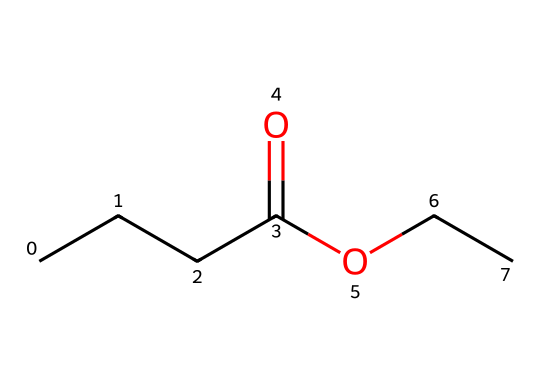What is the molecular formula of ethyl butyrate? To find the molecular formula, we need to count the number of each type of atom in the chemical structure represented by the SMILES. There are 6 carbon (C) atoms, 12 hydrogen (H) atoms, and 2 oxygen (O) atoms, which gives the molecular formula C6H12O2.
Answer: C6H12O2 How many carbon atoms are in ethyl butyrate? By examining the SMILES representation, we can count the carbon atoms. There are a total of 6 carbon atoms in the structure.
Answer: 6 What type of functional group is present in ethyl butyrate? Looking at the SMILES representation, we identify a carbonyl (C=O) and a hydroxy group (O), indicating the presence of an ester functional group.
Answer: ester What part of the structure contributes to its fruity smell? The ester functional group is responsible for the fruity aroma; it's a characteristic feature of many flavor and fragrance compounds.
Answer: ester group What is the relationship between ethyl butyrate and pineapple's smell? Ethyl butyrate is one of the key compounds contributing to the sweet, fruity smell associated with pineapples.
Answer: sweet fruity smell How does the presence of the ester group affect the properties of ethyl butyrate? The ester group contributes to the volatility and overall pleasant aroma of ethyl butyrate, making it appealing in fragrances and flavors.
Answer: pleasant aroma 